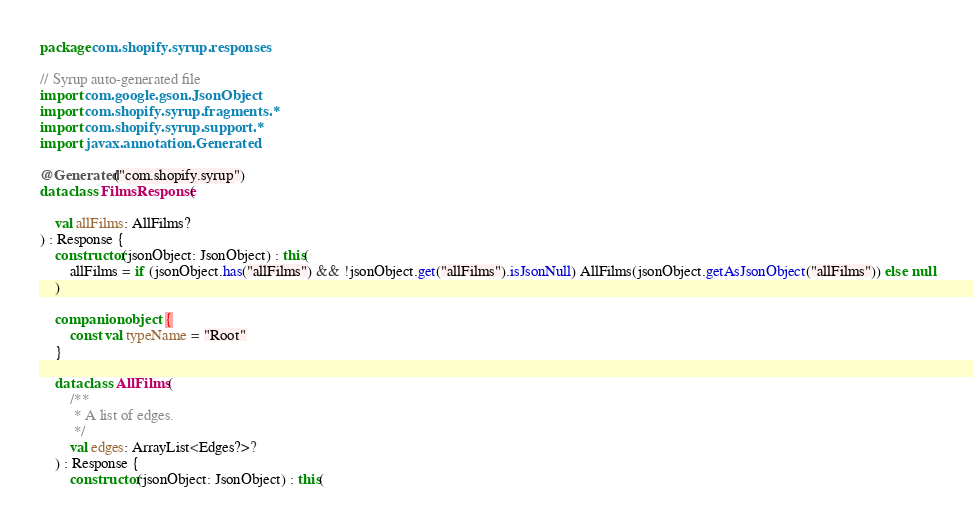<code> <loc_0><loc_0><loc_500><loc_500><_Kotlin_>
package com.shopify.syrup.responses

// Syrup auto-generated file
import com.google.gson.JsonObject
import com.shopify.syrup.fragments.*
import com.shopify.syrup.support.*
import javax.annotation.Generated

@Generated("com.shopify.syrup")
data class FilmsResponse(

    val allFilms: AllFilms?
) : Response {
    constructor(jsonObject: JsonObject) : this(
        allFilms = if (jsonObject.has("allFilms") && !jsonObject.get("allFilms").isJsonNull) AllFilms(jsonObject.getAsJsonObject("allFilms")) else null
    )

    companion object {
        const val typeName = "Root"
    }

    data class AllFilms(
        /**    
         * A list of edges.    
         */    
        val edges: ArrayList<Edges?>?
    ) : Response {
        constructor(jsonObject: JsonObject) : this(</code> 